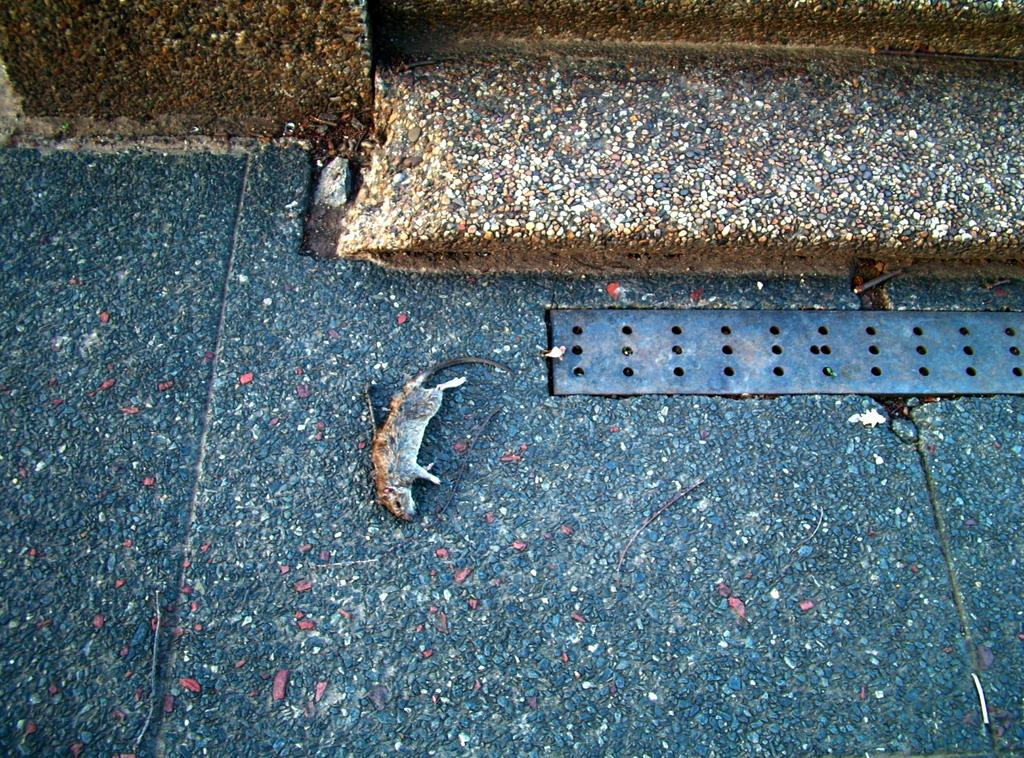What is the main subject in the foreground of the image? There is a rat in the foreground of the image. Where is the rat located? The rat is on the floor. What can be seen in the background of the image? There is a wall and steps in the background of the image. Can you describe the time of day when the image was taken? The image was taken during the day. How many girls are playing with the stone in the image? There are no girls or stones present in the image. 